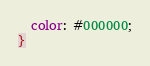<code> <loc_0><loc_0><loc_500><loc_500><_CSS_>  color: #000000;
}
</code> 